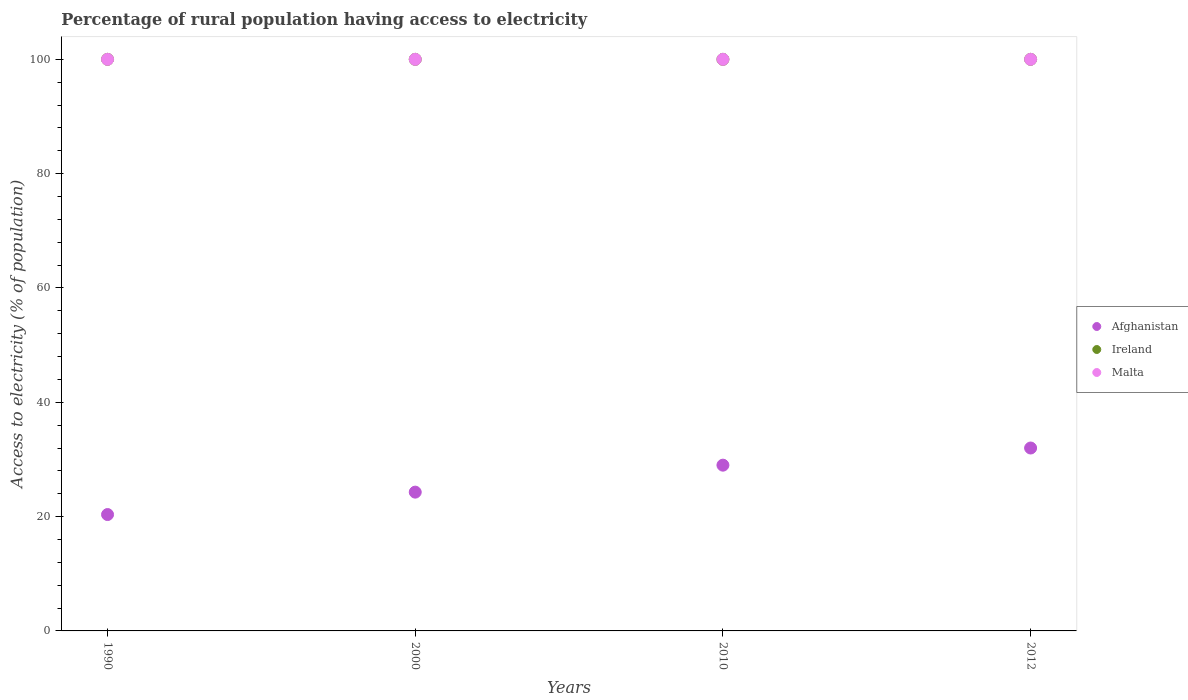What is the percentage of rural population having access to electricity in Malta in 2010?
Give a very brief answer. 100. Across all years, what is the maximum percentage of rural population having access to electricity in Ireland?
Ensure brevity in your answer.  100. Across all years, what is the minimum percentage of rural population having access to electricity in Malta?
Keep it short and to the point. 100. In which year was the percentage of rural population having access to electricity in Afghanistan maximum?
Keep it short and to the point. 2012. What is the total percentage of rural population having access to electricity in Ireland in the graph?
Offer a very short reply. 400. What is the difference between the percentage of rural population having access to electricity in Malta in 2000 and the percentage of rural population having access to electricity in Afghanistan in 2012?
Offer a very short reply. 68. What is the average percentage of rural population having access to electricity in Malta per year?
Keep it short and to the point. 100. In the year 2000, what is the difference between the percentage of rural population having access to electricity in Ireland and percentage of rural population having access to electricity in Afghanistan?
Offer a very short reply. 75.72. In how many years, is the percentage of rural population having access to electricity in Afghanistan greater than 28 %?
Your answer should be very brief. 2. What is the ratio of the percentage of rural population having access to electricity in Ireland in 2000 to that in 2012?
Offer a very short reply. 1. Is the percentage of rural population having access to electricity in Ireland in 2000 less than that in 2012?
Keep it short and to the point. No. Is the difference between the percentage of rural population having access to electricity in Ireland in 2010 and 2012 greater than the difference between the percentage of rural population having access to electricity in Afghanistan in 2010 and 2012?
Your response must be concise. Yes. What is the difference between the highest and the lowest percentage of rural population having access to electricity in Ireland?
Make the answer very short. 0. Is it the case that in every year, the sum of the percentage of rural population having access to electricity in Afghanistan and percentage of rural population having access to electricity in Malta  is greater than the percentage of rural population having access to electricity in Ireland?
Your answer should be very brief. Yes. How many years are there in the graph?
Your answer should be very brief. 4. What is the title of the graph?
Provide a succinct answer. Percentage of rural population having access to electricity. Does "Libya" appear as one of the legend labels in the graph?
Ensure brevity in your answer.  No. What is the label or title of the X-axis?
Provide a short and direct response. Years. What is the label or title of the Y-axis?
Your answer should be very brief. Access to electricity (% of population). What is the Access to electricity (% of population) in Afghanistan in 1990?
Keep it short and to the point. 20.36. What is the Access to electricity (% of population) of Ireland in 1990?
Provide a succinct answer. 100. What is the Access to electricity (% of population) in Afghanistan in 2000?
Your response must be concise. 24.28. What is the Access to electricity (% of population) of Ireland in 2000?
Ensure brevity in your answer.  100. What is the Access to electricity (% of population) in Malta in 2000?
Ensure brevity in your answer.  100. What is the Access to electricity (% of population) in Ireland in 2010?
Ensure brevity in your answer.  100. What is the Access to electricity (% of population) in Malta in 2010?
Offer a terse response. 100. Across all years, what is the maximum Access to electricity (% of population) of Afghanistan?
Provide a succinct answer. 32. Across all years, what is the minimum Access to electricity (% of population) of Afghanistan?
Offer a terse response. 20.36. Across all years, what is the minimum Access to electricity (% of population) in Malta?
Ensure brevity in your answer.  100. What is the total Access to electricity (% of population) of Afghanistan in the graph?
Keep it short and to the point. 105.64. What is the total Access to electricity (% of population) of Ireland in the graph?
Offer a terse response. 400. What is the total Access to electricity (% of population) in Malta in the graph?
Make the answer very short. 400. What is the difference between the Access to electricity (% of population) of Afghanistan in 1990 and that in 2000?
Give a very brief answer. -3.92. What is the difference between the Access to electricity (% of population) of Malta in 1990 and that in 2000?
Your answer should be compact. 0. What is the difference between the Access to electricity (% of population) of Afghanistan in 1990 and that in 2010?
Your response must be concise. -8.64. What is the difference between the Access to electricity (% of population) of Ireland in 1990 and that in 2010?
Offer a terse response. 0. What is the difference between the Access to electricity (% of population) in Afghanistan in 1990 and that in 2012?
Keep it short and to the point. -11.64. What is the difference between the Access to electricity (% of population) of Ireland in 1990 and that in 2012?
Make the answer very short. 0. What is the difference between the Access to electricity (% of population) of Afghanistan in 2000 and that in 2010?
Your response must be concise. -4.72. What is the difference between the Access to electricity (% of population) in Ireland in 2000 and that in 2010?
Ensure brevity in your answer.  0. What is the difference between the Access to electricity (% of population) in Afghanistan in 2000 and that in 2012?
Your response must be concise. -7.72. What is the difference between the Access to electricity (% of population) of Ireland in 2000 and that in 2012?
Make the answer very short. 0. What is the difference between the Access to electricity (% of population) of Malta in 2000 and that in 2012?
Your response must be concise. 0. What is the difference between the Access to electricity (% of population) of Afghanistan in 1990 and the Access to electricity (% of population) of Ireland in 2000?
Your answer should be compact. -79.64. What is the difference between the Access to electricity (% of population) of Afghanistan in 1990 and the Access to electricity (% of population) of Malta in 2000?
Provide a short and direct response. -79.64. What is the difference between the Access to electricity (% of population) of Ireland in 1990 and the Access to electricity (% of population) of Malta in 2000?
Your response must be concise. 0. What is the difference between the Access to electricity (% of population) of Afghanistan in 1990 and the Access to electricity (% of population) of Ireland in 2010?
Keep it short and to the point. -79.64. What is the difference between the Access to electricity (% of population) in Afghanistan in 1990 and the Access to electricity (% of population) in Malta in 2010?
Make the answer very short. -79.64. What is the difference between the Access to electricity (% of population) in Afghanistan in 1990 and the Access to electricity (% of population) in Ireland in 2012?
Make the answer very short. -79.64. What is the difference between the Access to electricity (% of population) of Afghanistan in 1990 and the Access to electricity (% of population) of Malta in 2012?
Ensure brevity in your answer.  -79.64. What is the difference between the Access to electricity (% of population) of Afghanistan in 2000 and the Access to electricity (% of population) of Ireland in 2010?
Your response must be concise. -75.72. What is the difference between the Access to electricity (% of population) in Afghanistan in 2000 and the Access to electricity (% of population) in Malta in 2010?
Make the answer very short. -75.72. What is the difference between the Access to electricity (% of population) in Ireland in 2000 and the Access to electricity (% of population) in Malta in 2010?
Your answer should be compact. 0. What is the difference between the Access to electricity (% of population) of Afghanistan in 2000 and the Access to electricity (% of population) of Ireland in 2012?
Offer a terse response. -75.72. What is the difference between the Access to electricity (% of population) of Afghanistan in 2000 and the Access to electricity (% of population) of Malta in 2012?
Make the answer very short. -75.72. What is the difference between the Access to electricity (% of population) in Ireland in 2000 and the Access to electricity (% of population) in Malta in 2012?
Provide a succinct answer. 0. What is the difference between the Access to electricity (% of population) of Afghanistan in 2010 and the Access to electricity (% of population) of Ireland in 2012?
Give a very brief answer. -71. What is the difference between the Access to electricity (% of population) of Afghanistan in 2010 and the Access to electricity (% of population) of Malta in 2012?
Your answer should be compact. -71. What is the average Access to electricity (% of population) in Afghanistan per year?
Your response must be concise. 26.41. What is the average Access to electricity (% of population) in Ireland per year?
Offer a very short reply. 100. In the year 1990, what is the difference between the Access to electricity (% of population) of Afghanistan and Access to electricity (% of population) of Ireland?
Your answer should be very brief. -79.64. In the year 1990, what is the difference between the Access to electricity (% of population) in Afghanistan and Access to electricity (% of population) in Malta?
Offer a terse response. -79.64. In the year 2000, what is the difference between the Access to electricity (% of population) of Afghanistan and Access to electricity (% of population) of Ireland?
Your response must be concise. -75.72. In the year 2000, what is the difference between the Access to electricity (% of population) of Afghanistan and Access to electricity (% of population) of Malta?
Your response must be concise. -75.72. In the year 2010, what is the difference between the Access to electricity (% of population) in Afghanistan and Access to electricity (% of population) in Ireland?
Your answer should be very brief. -71. In the year 2010, what is the difference between the Access to electricity (% of population) of Afghanistan and Access to electricity (% of population) of Malta?
Provide a succinct answer. -71. In the year 2010, what is the difference between the Access to electricity (% of population) in Ireland and Access to electricity (% of population) in Malta?
Your answer should be compact. 0. In the year 2012, what is the difference between the Access to electricity (% of population) of Afghanistan and Access to electricity (% of population) of Ireland?
Offer a very short reply. -68. In the year 2012, what is the difference between the Access to electricity (% of population) of Afghanistan and Access to electricity (% of population) of Malta?
Your answer should be compact. -68. What is the ratio of the Access to electricity (% of population) in Afghanistan in 1990 to that in 2000?
Offer a terse response. 0.84. What is the ratio of the Access to electricity (% of population) in Afghanistan in 1990 to that in 2010?
Your answer should be very brief. 0.7. What is the ratio of the Access to electricity (% of population) of Ireland in 1990 to that in 2010?
Keep it short and to the point. 1. What is the ratio of the Access to electricity (% of population) in Afghanistan in 1990 to that in 2012?
Make the answer very short. 0.64. What is the ratio of the Access to electricity (% of population) in Afghanistan in 2000 to that in 2010?
Your answer should be compact. 0.84. What is the ratio of the Access to electricity (% of population) in Afghanistan in 2000 to that in 2012?
Your answer should be compact. 0.76. What is the ratio of the Access to electricity (% of population) in Ireland in 2000 to that in 2012?
Provide a succinct answer. 1. What is the ratio of the Access to electricity (% of population) in Malta in 2000 to that in 2012?
Keep it short and to the point. 1. What is the ratio of the Access to electricity (% of population) of Afghanistan in 2010 to that in 2012?
Make the answer very short. 0.91. What is the ratio of the Access to electricity (% of population) of Ireland in 2010 to that in 2012?
Offer a terse response. 1. What is the difference between the highest and the second highest Access to electricity (% of population) of Afghanistan?
Give a very brief answer. 3. What is the difference between the highest and the second highest Access to electricity (% of population) of Ireland?
Provide a succinct answer. 0. What is the difference between the highest and the second highest Access to electricity (% of population) of Malta?
Offer a terse response. 0. What is the difference between the highest and the lowest Access to electricity (% of population) of Afghanistan?
Offer a very short reply. 11.64. 